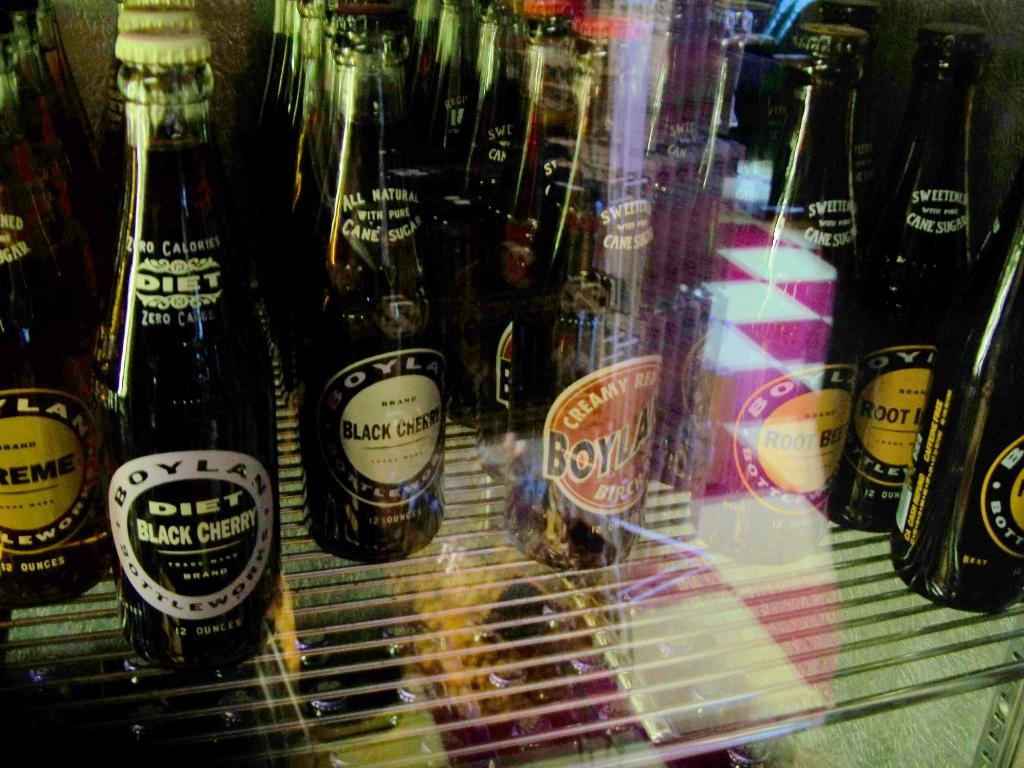<image>
Render a clear and concise summary of the photo. A bottle of Boylan Diet Black Cherry is on the shelf with a few other varieties. 